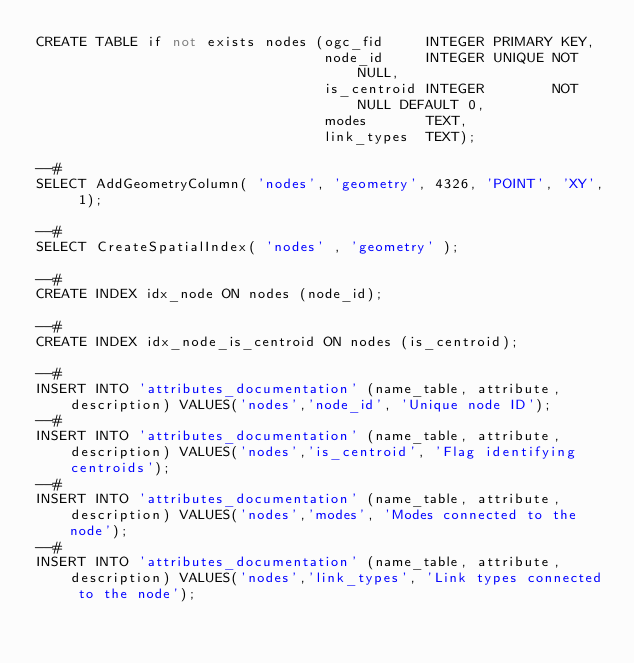<code> <loc_0><loc_0><loc_500><loc_500><_SQL_>CREATE TABLE if not exists nodes (ogc_fid     INTEGER PRIMARY KEY,
                                  node_id     INTEGER UNIQUE NOT NULL,
                                  is_centroid INTEGER        NOT NULL DEFAULT 0,
                                  modes       TEXT,
                                  link_types  TEXT);

--#
SELECT AddGeometryColumn( 'nodes', 'geometry', 4326, 'POINT', 'XY', 1);

--#
SELECT CreateSpatialIndex( 'nodes' , 'geometry' );

--#
CREATE INDEX idx_node ON nodes (node_id);

--#
CREATE INDEX idx_node_is_centroid ON nodes (is_centroid);

--#
INSERT INTO 'attributes_documentation' (name_table, attribute, description) VALUES('nodes','node_id', 'Unique node ID');
--#
INSERT INTO 'attributes_documentation' (name_table, attribute, description) VALUES('nodes','is_centroid', 'Flag identifying centroids');
--#
INSERT INTO 'attributes_documentation' (name_table, attribute, description) VALUES('nodes','modes', 'Modes connected to the node');
--#
INSERT INTO 'attributes_documentation' (name_table, attribute, description) VALUES('nodes','link_types', 'Link types connected to the node');
</code> 